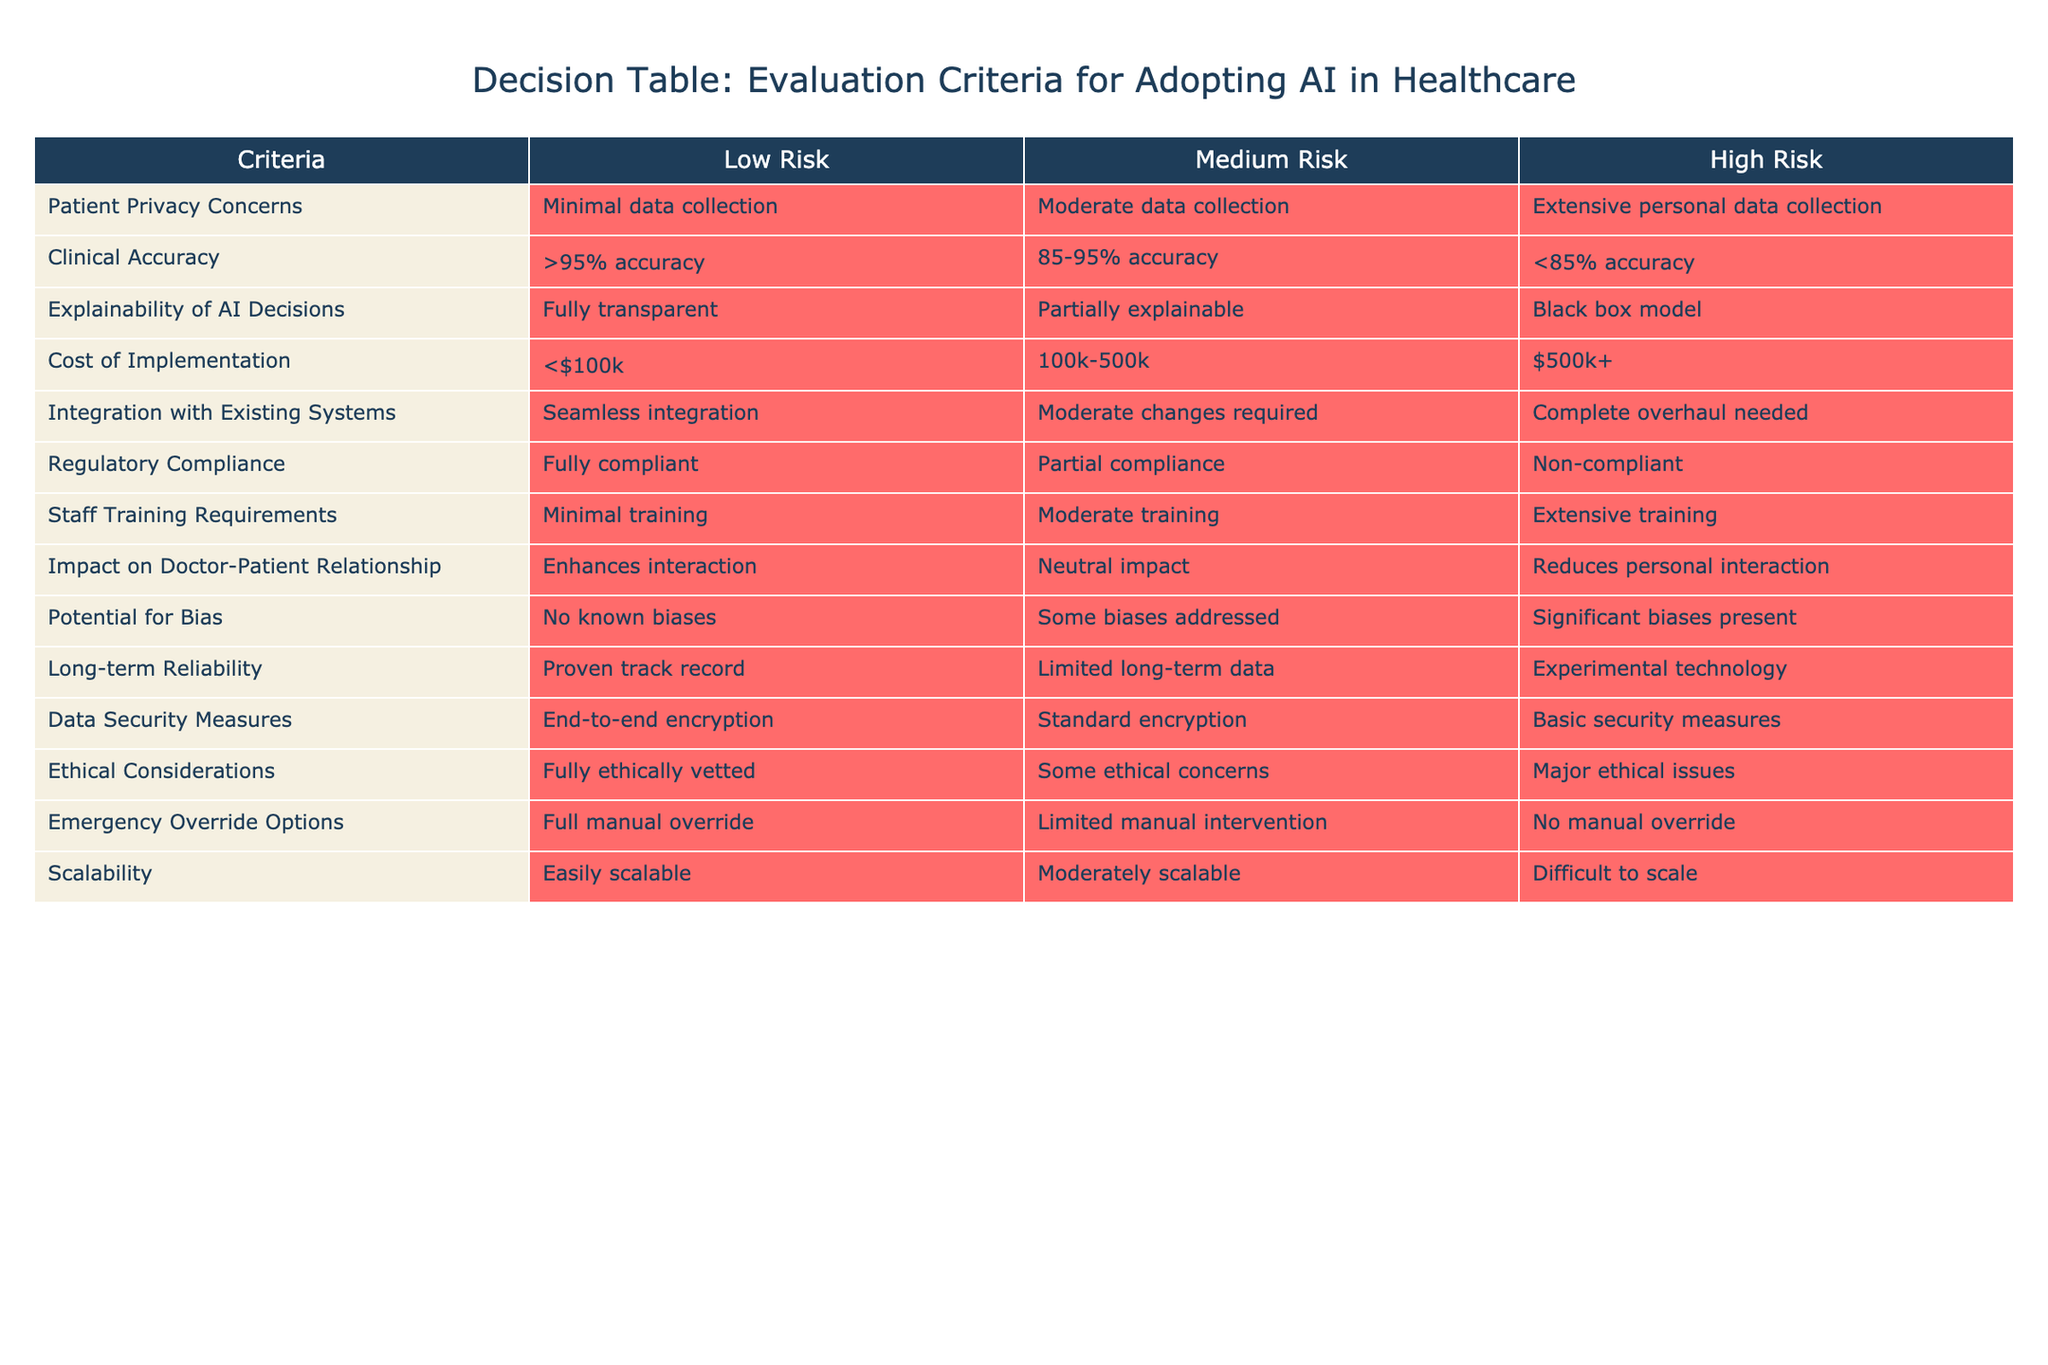What is the cost of implementation for a low-risk evaluation? According to the table, a low-risk evaluation in the cost of implementation category is defined as costing less than $100k.
Answer: Less than $100k What level of clinical accuracy is considered high risk? The table indicates that a high-risk evaluation in clinical accuracy is categorized as having less than 85% accuracy.
Answer: Less than 85% accuracy Is extensive personal data collection associated with low-risk evaluation? The data indicates that extensive personal data collection falls under the high-risk category for patient privacy concerns, thus it is not associated with low risk.
Answer: No What is the median level of explainability for AI decisions? The explainability levels are categorized as fully transparent, partially explainable, and a black box model. The middle option, which is partial explainability, represents the median level of explainability.
Answer: Partially explainable Based on the evaluations, which criteria have the potential for bias categorized as high risk? The table states that criteria with significant biases present are considered high risk. Thus, potential for bias is the criterion that fits this category.
Answer: Potential for bias If the cost of implementation is between $100k and $500k, what is the risk level? The table specifies that implementation costs within this range are classified as medium risk. Therefore, if costs are between $100k and $500k, the risk level is medium.
Answer: Medium risk Can a system be fully compliant with regulations and still have ethical issues? The table indicates that it is possible for a system to be fully compliant with regulations while still having some ethical concerns, thus the answer is yes.
Answer: Yes Which criteria encompass both minimal training requirements and end-to-end encryption? From the table, the criteria that exhibit minimal training requirements correspond with low risk. At the same time, data security measures that have end-to-end encryption also fall under the low-risk category. Thus, both criteria relate to low risk.
Answer: Minimal training requirements and end-to-end encryption What could be the implications of a black box model in terms of explainability? A black box model, according to the table, is categorized under the high-risk level for explainability, indicating that the decisions made by such AI systems are not transparent, potentially leading to challenges in trust and decision-making among users.
Answer: High risk for explainability 